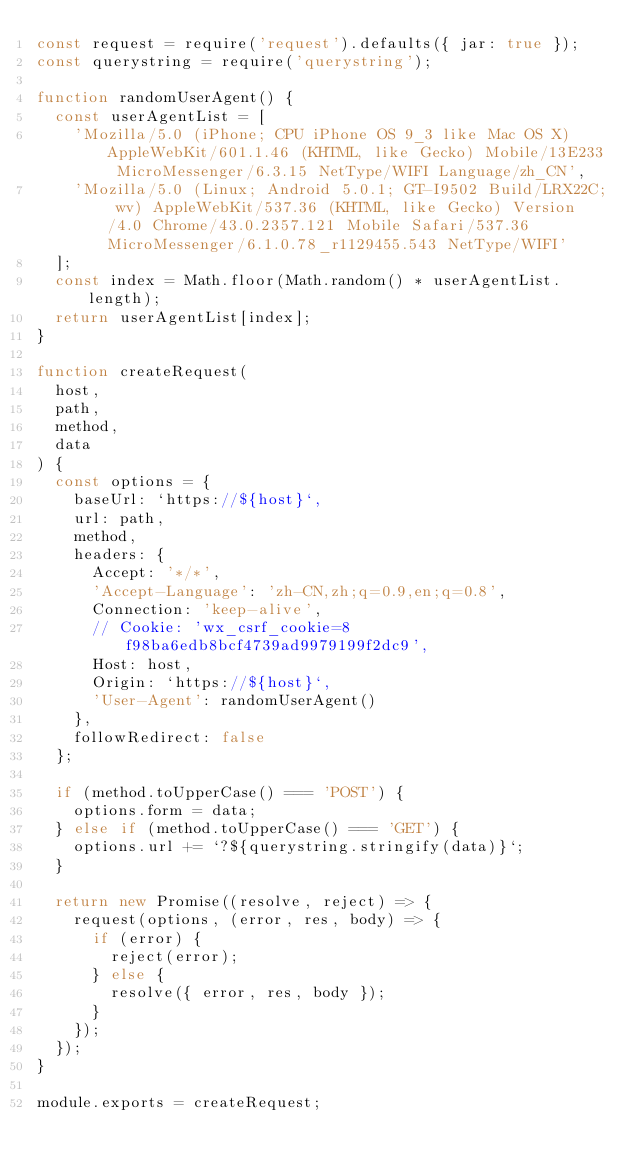Convert code to text. <code><loc_0><loc_0><loc_500><loc_500><_JavaScript_>const request = require('request').defaults({ jar: true });
const querystring = require('querystring');

function randomUserAgent() {
  const userAgentList = [
    'Mozilla/5.0 (iPhone; CPU iPhone OS 9_3 like Mac OS X) AppleWebKit/601.1.46 (KHTML, like Gecko) Mobile/13E233 MicroMessenger/6.3.15 NetType/WIFI Language/zh_CN',
    'Mozilla/5.0 (Linux; Android 5.0.1; GT-I9502 Build/LRX22C; wv) AppleWebKit/537.36 (KHTML, like Gecko) Version/4.0 Chrome/43.0.2357.121 Mobile Safari/537.36 MicroMessenger/6.1.0.78_r1129455.543 NetType/WIFI'
  ];
  const index = Math.floor(Math.random() * userAgentList.length);
  return userAgentList[index];
}

function createRequest(
  host,
  path,
  method,
  data
) {
  const options = {
    baseUrl: `https://${host}`,
    url: path,
    method,
    headers: {
      Accept: '*/*',
      'Accept-Language': 'zh-CN,zh;q=0.9,en;q=0.8',
      Connection: 'keep-alive',
      // Cookie: 'wx_csrf_cookie=8f98ba6edb8bcf4739ad9979199f2dc9',
      Host: host,
      Origin: `https://${host}`,
      'User-Agent': randomUserAgent()
    },
    followRedirect: false
  };

  if (method.toUpperCase() === 'POST') {
    options.form = data;
  } else if (method.toUpperCase() === 'GET') {
    options.url += `?${querystring.stringify(data)}`;
  }

  return new Promise((resolve, reject) => {
    request(options, (error, res, body) => {
      if (error) {
        reject(error);
      } else {
        resolve({ error, res, body });
      }
    });
  });
}

module.exports = createRequest;
</code> 